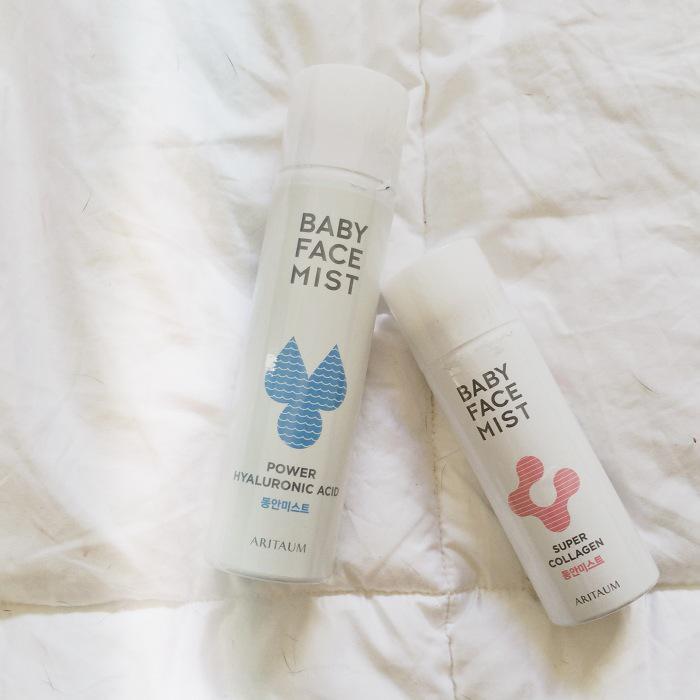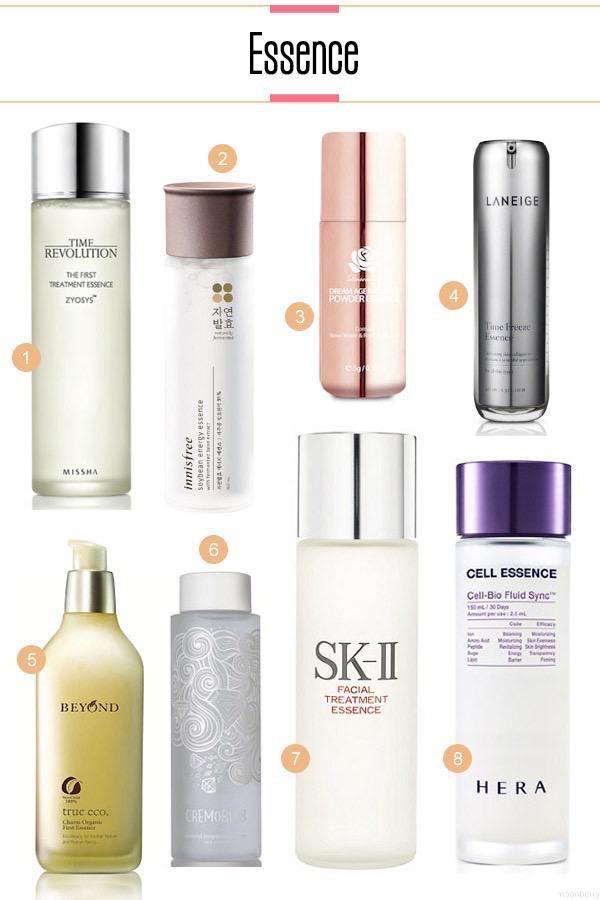The first image is the image on the left, the second image is the image on the right. Assess this claim about the two images: "Four or more skin products are standing upright on a counter in the left photo.". Correct or not? Answer yes or no. No. The first image is the image on the left, the second image is the image on the right. For the images shown, is this caption "An image shows exactly one skincare product, which has a gold cap." true? Answer yes or no. No. 